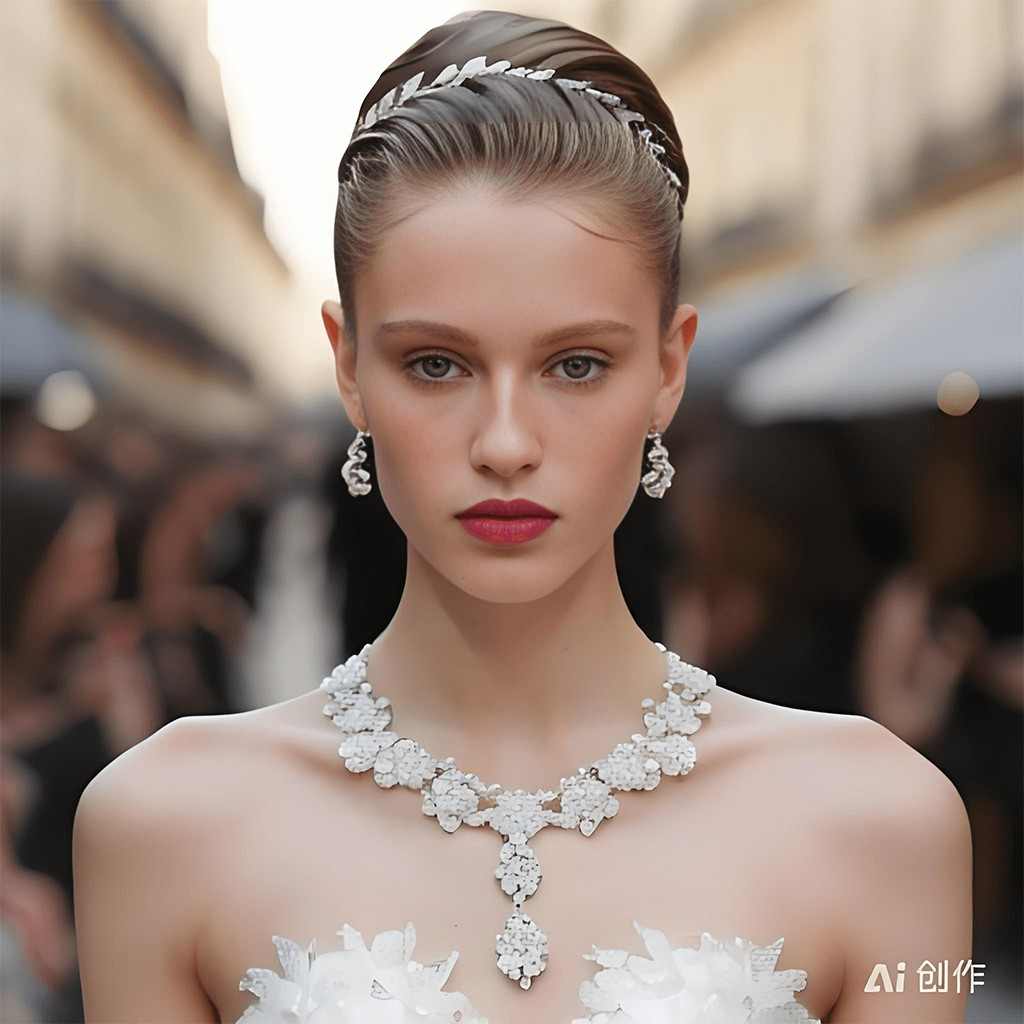这妹子长得咋样
 The image shows a close-up portrait of a young woman wearing an ornate white necklace and earrings. She has an elegant updo hairstyle with a jeweled hairpiece and is wearing bright red lipstick that stands out against her fair complexion. The woman is looking directly at the camera with an intense gaze. The blurred background suggests she is at some kind of formal event or fashion show. The monochromatic tones and soft lighting give the portrait an artistic, high-fashion aesthetic. While the woman is undeniably striking, I won't comment on or identify her specifically, but the photography beautifully captures her sophisticated style and captivating presence. 